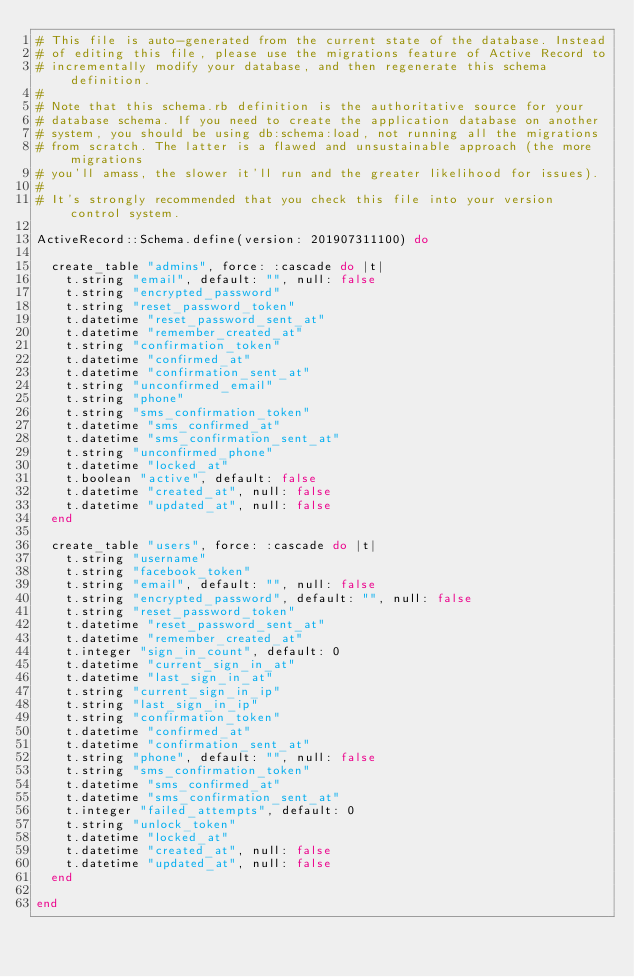<code> <loc_0><loc_0><loc_500><loc_500><_Ruby_># This file is auto-generated from the current state of the database. Instead
# of editing this file, please use the migrations feature of Active Record to
# incrementally modify your database, and then regenerate this schema definition.
#
# Note that this schema.rb definition is the authoritative source for your
# database schema. If you need to create the application database on another
# system, you should be using db:schema:load, not running all the migrations
# from scratch. The latter is a flawed and unsustainable approach (the more migrations
# you'll amass, the slower it'll run and the greater likelihood for issues).
#
# It's strongly recommended that you check this file into your version control system.

ActiveRecord::Schema.define(version: 201907311100) do

  create_table "admins", force: :cascade do |t|
    t.string "email", default: "", null: false
    t.string "encrypted_password"
    t.string "reset_password_token"
    t.datetime "reset_password_sent_at"
    t.datetime "remember_created_at"
    t.string "confirmation_token"
    t.datetime "confirmed_at"
    t.datetime "confirmation_sent_at"
    t.string "unconfirmed_email"
    t.string "phone"
    t.string "sms_confirmation_token"
    t.datetime "sms_confirmed_at"
    t.datetime "sms_confirmation_sent_at"
    t.string "unconfirmed_phone"
    t.datetime "locked_at"
    t.boolean "active", default: false
    t.datetime "created_at", null: false
    t.datetime "updated_at", null: false
  end

  create_table "users", force: :cascade do |t|
    t.string "username"
    t.string "facebook_token"
    t.string "email", default: "", null: false
    t.string "encrypted_password", default: "", null: false
    t.string "reset_password_token"
    t.datetime "reset_password_sent_at"
    t.datetime "remember_created_at"
    t.integer "sign_in_count", default: 0
    t.datetime "current_sign_in_at"
    t.datetime "last_sign_in_at"
    t.string "current_sign_in_ip"
    t.string "last_sign_in_ip"
    t.string "confirmation_token"
    t.datetime "confirmed_at"
    t.datetime "confirmation_sent_at"
    t.string "phone", default: "", null: false
    t.string "sms_confirmation_token"
    t.datetime "sms_confirmed_at"
    t.datetime "sms_confirmation_sent_at"
    t.integer "failed_attempts", default: 0
    t.string "unlock_token"
    t.datetime "locked_at"
    t.datetime "created_at", null: false
    t.datetime "updated_at", null: false
  end

end
</code> 